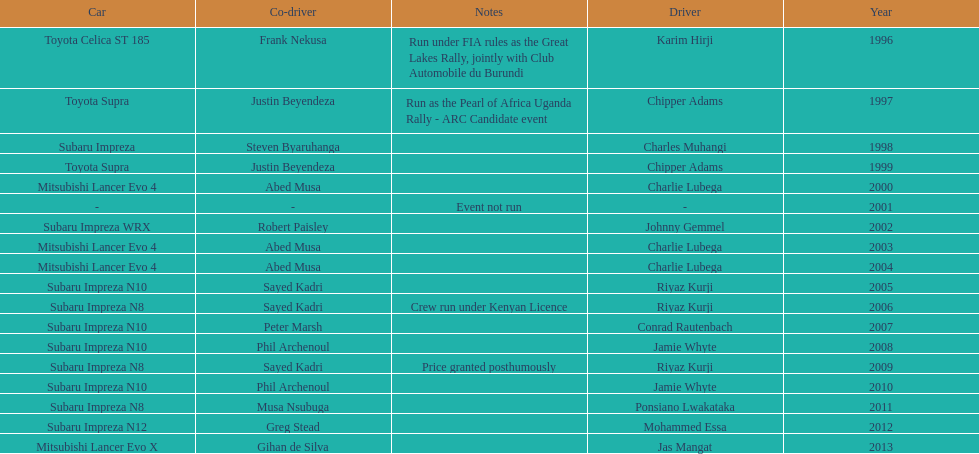Chipper adams and justin beyendeza have how mnay wins? 2. 